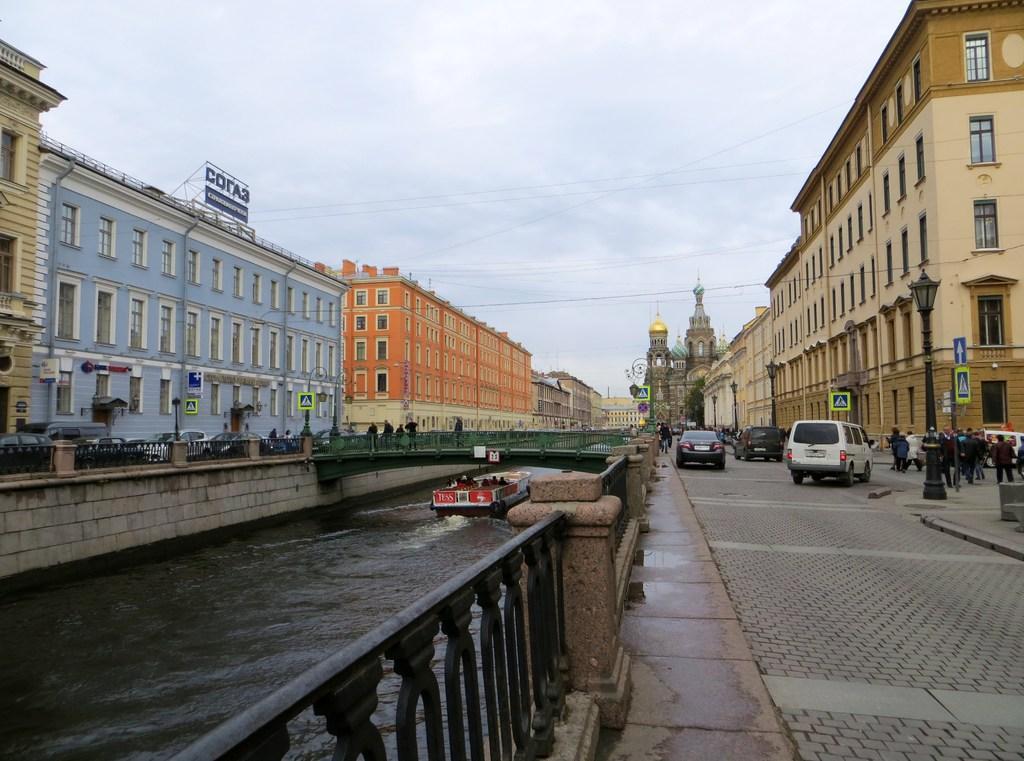Can you describe this image briefly? Here on the right side there are vehicles and few people walking on the road and we can see buildings,windows,sign board poles. We can see few people riding in a boat on the water and we can see a bridge. On the left there are few people walking,standing on the road and there are buildings,windows,poles and there are clouds in the sky. 